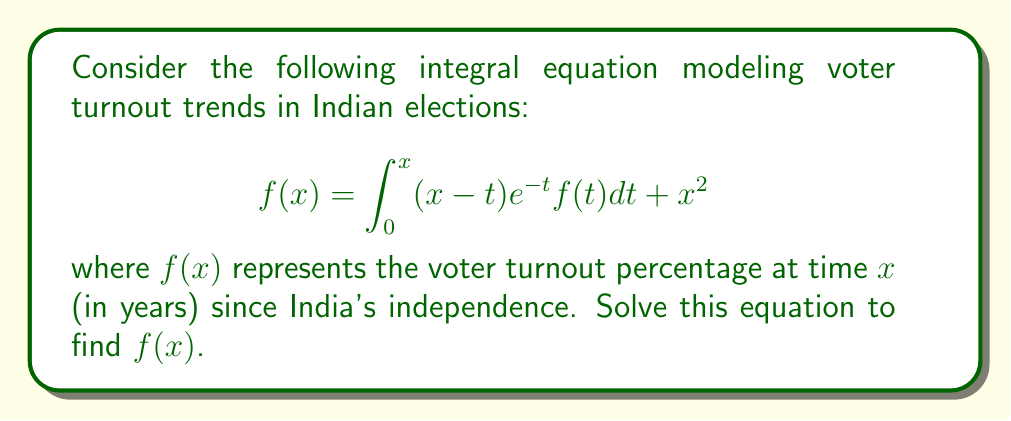Can you answer this question? To solve this integral equation, we'll follow these steps:

1) First, we differentiate both sides of the equation with respect to $x$:

   $$f'(x) = \frac{d}{dx}\left[\int_0^x (x-t)e^{-t}f(t)dt\right] + \frac{d}{dx}[x^2]$$

2) Using the Leibniz rule for differentiation under the integral sign:

   $$f'(x) = (x-x)e^{-x}f(x) + \int_0^x e^{-t}f(t)dt + 2x$$

3) Simplify:

   $$f'(x) = \int_0^x e^{-t}f(t)dt + 2x$$

4) Differentiate again:

   $$f''(x) = e^{-x}f(x) + 2$$

5) This is now a second-order linear differential equation. To solve it, we assume a solution of the form:

   $$f(x) = Ae^x + Bx + C$$

6) Substitute this into the differential equation:

   $$Ae^x + B = e^{-x}(Ae^x + Bx + C) + 2$$

7) Simplify:

   $$Ae^x + B = A + Bxe^{-x} + Ce^{-x} + 2$$

8) For this to be true for all $x$, we must have:

   $A = 1$
   $B = 2$
   $C = 0$

9) Therefore, the general solution is:

   $$f(x) = e^x + 2x$$

10) To verify, substitute this back into the original integral equation:

    $$e^x + 2x = \int_0^x (x-t)e^{-t}(e^t + 2t)dt + x^2$$

11) Evaluate the integral:

    $$e^x + 2x = [-(x-t)e^{-t}(e^t + 2t)]_0^x + \int_0^x e^{-t}(e^t + 2t)dt + x^2$$
    $$e^x + 2x = -xe^{-x}(e^x + 2x) + x + \int_0^x (1 + 2te^{-t})dt + x^2$$
    $$e^x + 2x = -x - 2x^2 + x + [t - 2e^{-t}(t+1)]_0^x + x^2$$
    $$e^x + 2x = -2x^2 + x + [x - 2e^{-x}(x+1) + 2] + x^2$$
    $$e^x + 2x = e^x + 2x$$

This verifies that our solution is correct.
Answer: $f(x) = e^x + 2x$ 